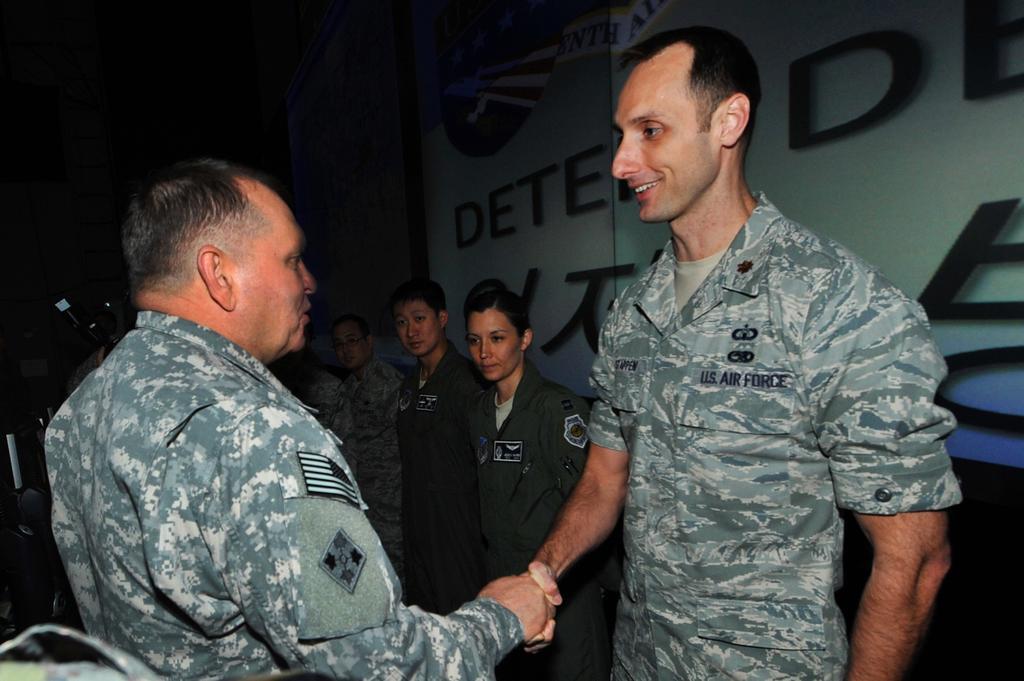Could you give a brief overview of what you see in this image? In this picture, we can see a few people among them we can see two persons are shaking their hands, we can see some text on the wall, and the dark background. 